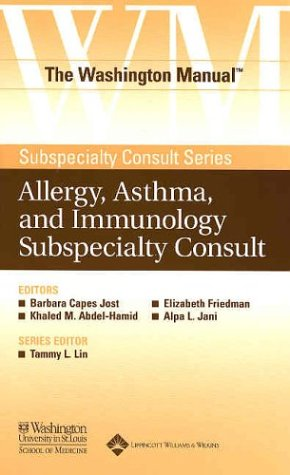Can you tell me more about the specific topics covered in this book? This book offers in-depth coverage of allergy, asthma, and immunology, including diagnostic techniques, treatment protocols, and management strategies for various conditions related to these disciplines. 